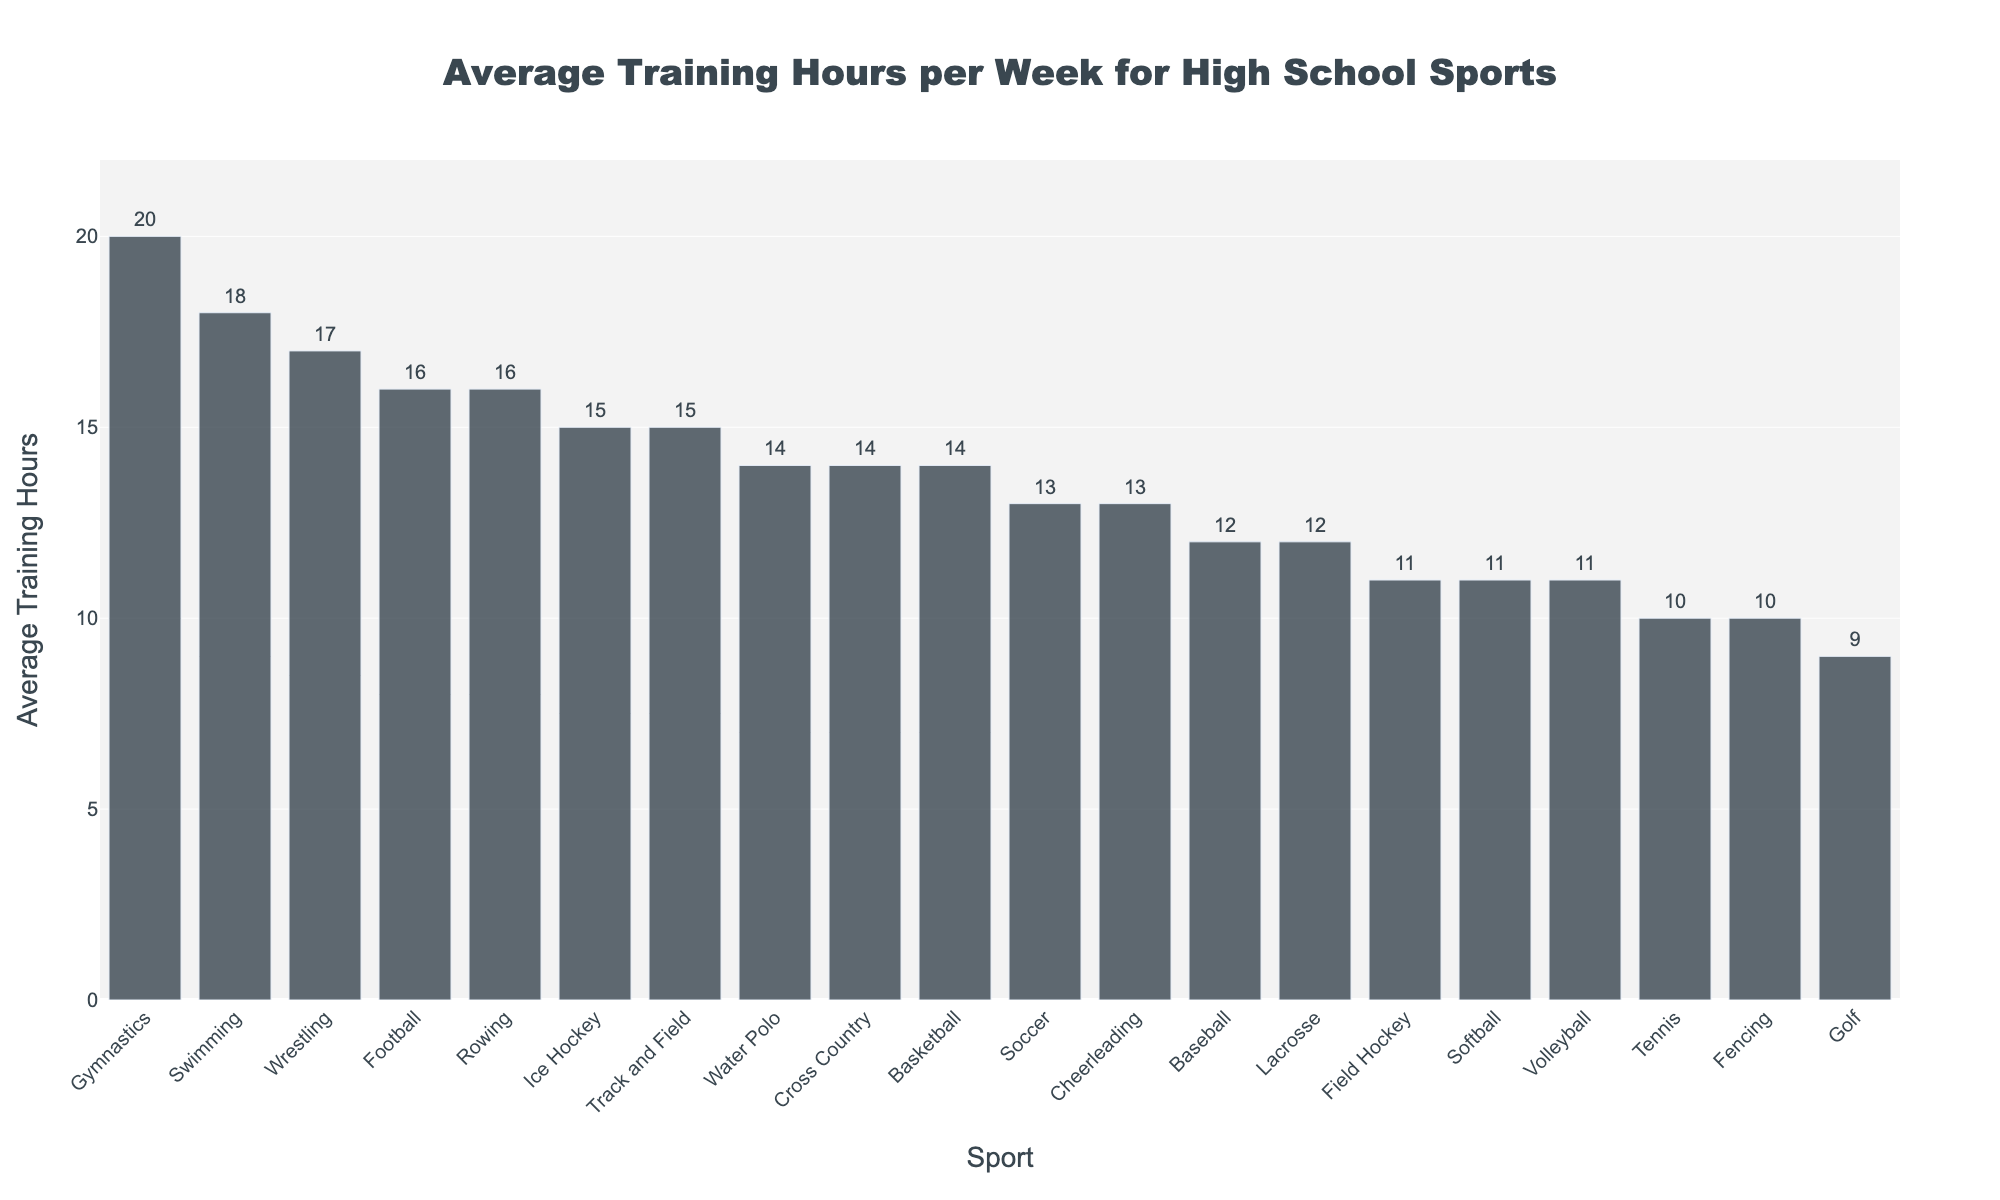Which sport requires the most training hours per week? From the bar chart, the tallest bar representing Gymnastics indicates it requires the most training hours per week
Answer: Gymnastics Which two sports have equal average training hours per week and how many hours are they? From the bar chart, Tennis and Fencing both have bars of the same height, representing 10 training hours per week
Answer: Tennis and Fencing, 10 hours How does the average training hours per week for Track and Field compare to that for Ice Hockey? The bar for Track and Field and Ice Hockey both have the same height, indicating they both have 15 average training hours per week
Answer: Track and Field and Ice Hockey both have 15 hours What is the difference in average training hours per week between the sport with the highest and the sport with the lowest training hours? The highest is Gymnastics with 20 hours, and the lowest is Golf with 9 hours. The difference is 20 - 9
Answer: 11 hours Add the average training hours per week of Soccer, Basketball, and Football. What’s the total? Soccer has 13 hours, Basketball has 14 hours, and Football has 16 hours. Summing these up: 13 + 14 + 16 equals
Answer: 43 hours How many sports require more than 15 average training hours per week? From the bar chart, Swimming, Wrestling, Gymnastics, and Rowing have bars exceeding the 15-hour mark. This results in 4 sports
Answer: 4 sports Are there any sports that have an average training hour of exactly 12 per week? From the bar chart, Baseball and Lacrosse both have bars depicting 12-hour training weeks
Answer: Baseball and Lacrosse Compare the average training hours per week between Field Hockey and Volleyball. The bar for Volleyball is slightly lower than Field Hockey, but both indicate 11 average training hours per week
Answer: Both 11 hours What is the median value of the average training hours per week for all the sports? Listing the training hours in ascending order: 9, 10, 10, 11, 11, 11, 12, 12, 13, 13, 14, 14, 15, 15, 16, 16, 17, 18, 20. The median is the 10th value, which is
Answer: 14 hours How much greater are the average training hours for Swimming compared to Softball? Swimming has 18 hours, while Softball has 11 hours. The difference is 18 - 11
Answer: 7 hours 